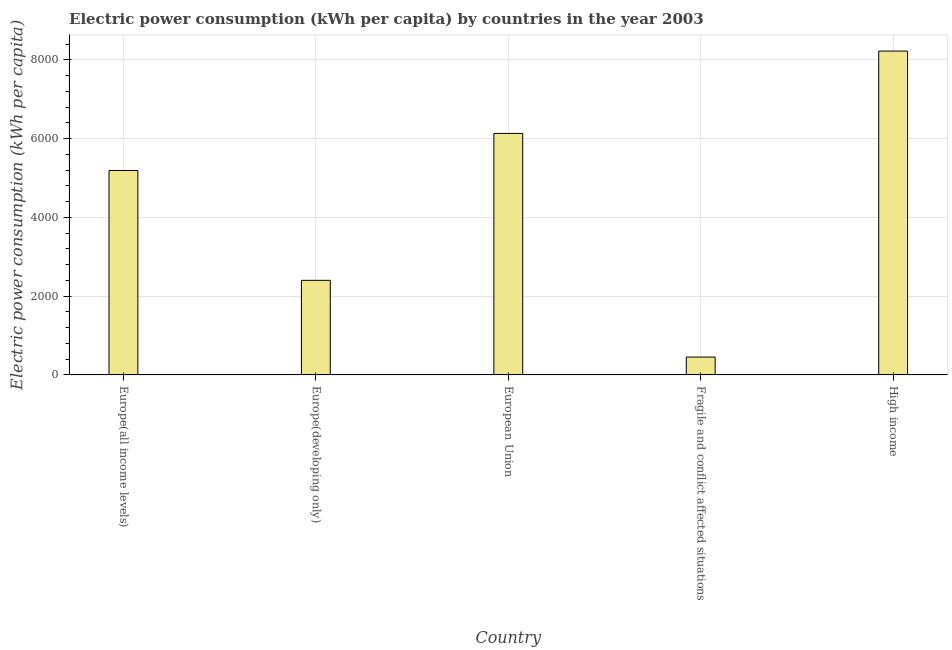Does the graph contain any zero values?
Offer a terse response. No. What is the title of the graph?
Ensure brevity in your answer.  Electric power consumption (kWh per capita) by countries in the year 2003. What is the label or title of the X-axis?
Offer a very short reply. Country. What is the label or title of the Y-axis?
Offer a terse response. Electric power consumption (kWh per capita). What is the electric power consumption in European Union?
Your answer should be very brief. 6131.46. Across all countries, what is the maximum electric power consumption?
Give a very brief answer. 8222.09. Across all countries, what is the minimum electric power consumption?
Offer a terse response. 452.94. In which country was the electric power consumption maximum?
Your response must be concise. High income. In which country was the electric power consumption minimum?
Offer a terse response. Fragile and conflict affected situations. What is the sum of the electric power consumption?
Provide a succinct answer. 2.24e+04. What is the difference between the electric power consumption in Fragile and conflict affected situations and High income?
Offer a terse response. -7769.15. What is the average electric power consumption per country?
Provide a short and direct response. 4479.58. What is the median electric power consumption?
Provide a short and direct response. 5190.34. What is the ratio of the electric power consumption in Europe(all income levels) to that in Europe(developing only)?
Your answer should be very brief. 2.16. Is the electric power consumption in Europe(all income levels) less than that in Fragile and conflict affected situations?
Provide a short and direct response. No. What is the difference between the highest and the second highest electric power consumption?
Your response must be concise. 2090.63. Is the sum of the electric power consumption in Europe(all income levels) and High income greater than the maximum electric power consumption across all countries?
Your answer should be compact. Yes. What is the difference between the highest and the lowest electric power consumption?
Provide a short and direct response. 7769.15. In how many countries, is the electric power consumption greater than the average electric power consumption taken over all countries?
Ensure brevity in your answer.  3. What is the difference between two consecutive major ticks on the Y-axis?
Keep it short and to the point. 2000. What is the Electric power consumption (kWh per capita) of Europe(all income levels)?
Ensure brevity in your answer.  5190.34. What is the Electric power consumption (kWh per capita) of Europe(developing only)?
Your answer should be compact. 2401.05. What is the Electric power consumption (kWh per capita) in European Union?
Ensure brevity in your answer.  6131.46. What is the Electric power consumption (kWh per capita) in Fragile and conflict affected situations?
Offer a very short reply. 452.94. What is the Electric power consumption (kWh per capita) of High income?
Keep it short and to the point. 8222.09. What is the difference between the Electric power consumption (kWh per capita) in Europe(all income levels) and Europe(developing only)?
Make the answer very short. 2789.28. What is the difference between the Electric power consumption (kWh per capita) in Europe(all income levels) and European Union?
Provide a succinct answer. -941.13. What is the difference between the Electric power consumption (kWh per capita) in Europe(all income levels) and Fragile and conflict affected situations?
Your answer should be very brief. 4737.4. What is the difference between the Electric power consumption (kWh per capita) in Europe(all income levels) and High income?
Give a very brief answer. -3031.75. What is the difference between the Electric power consumption (kWh per capita) in Europe(developing only) and European Union?
Give a very brief answer. -3730.41. What is the difference between the Electric power consumption (kWh per capita) in Europe(developing only) and Fragile and conflict affected situations?
Offer a terse response. 1948.11. What is the difference between the Electric power consumption (kWh per capita) in Europe(developing only) and High income?
Keep it short and to the point. -5821.04. What is the difference between the Electric power consumption (kWh per capita) in European Union and Fragile and conflict affected situations?
Give a very brief answer. 5678.52. What is the difference between the Electric power consumption (kWh per capita) in European Union and High income?
Your answer should be compact. -2090.63. What is the difference between the Electric power consumption (kWh per capita) in Fragile and conflict affected situations and High income?
Your response must be concise. -7769.15. What is the ratio of the Electric power consumption (kWh per capita) in Europe(all income levels) to that in Europe(developing only)?
Keep it short and to the point. 2.16. What is the ratio of the Electric power consumption (kWh per capita) in Europe(all income levels) to that in European Union?
Your answer should be compact. 0.85. What is the ratio of the Electric power consumption (kWh per capita) in Europe(all income levels) to that in Fragile and conflict affected situations?
Make the answer very short. 11.46. What is the ratio of the Electric power consumption (kWh per capita) in Europe(all income levels) to that in High income?
Keep it short and to the point. 0.63. What is the ratio of the Electric power consumption (kWh per capita) in Europe(developing only) to that in European Union?
Your answer should be very brief. 0.39. What is the ratio of the Electric power consumption (kWh per capita) in Europe(developing only) to that in Fragile and conflict affected situations?
Your response must be concise. 5.3. What is the ratio of the Electric power consumption (kWh per capita) in Europe(developing only) to that in High income?
Keep it short and to the point. 0.29. What is the ratio of the Electric power consumption (kWh per capita) in European Union to that in Fragile and conflict affected situations?
Your answer should be very brief. 13.54. What is the ratio of the Electric power consumption (kWh per capita) in European Union to that in High income?
Ensure brevity in your answer.  0.75. What is the ratio of the Electric power consumption (kWh per capita) in Fragile and conflict affected situations to that in High income?
Your answer should be very brief. 0.06. 